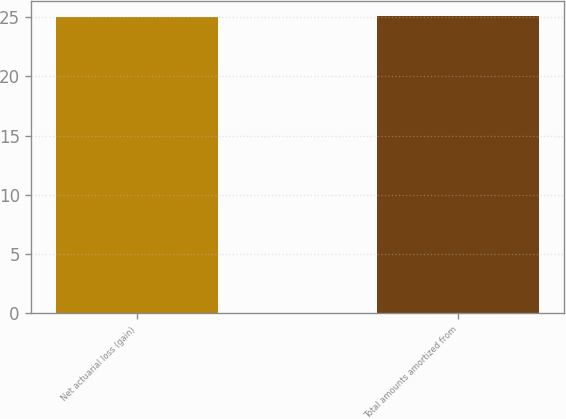Convert chart. <chart><loc_0><loc_0><loc_500><loc_500><bar_chart><fcel>Net actuarial loss (gain)<fcel>Total amounts amortized from<nl><fcel>25<fcel>25.1<nl></chart> 